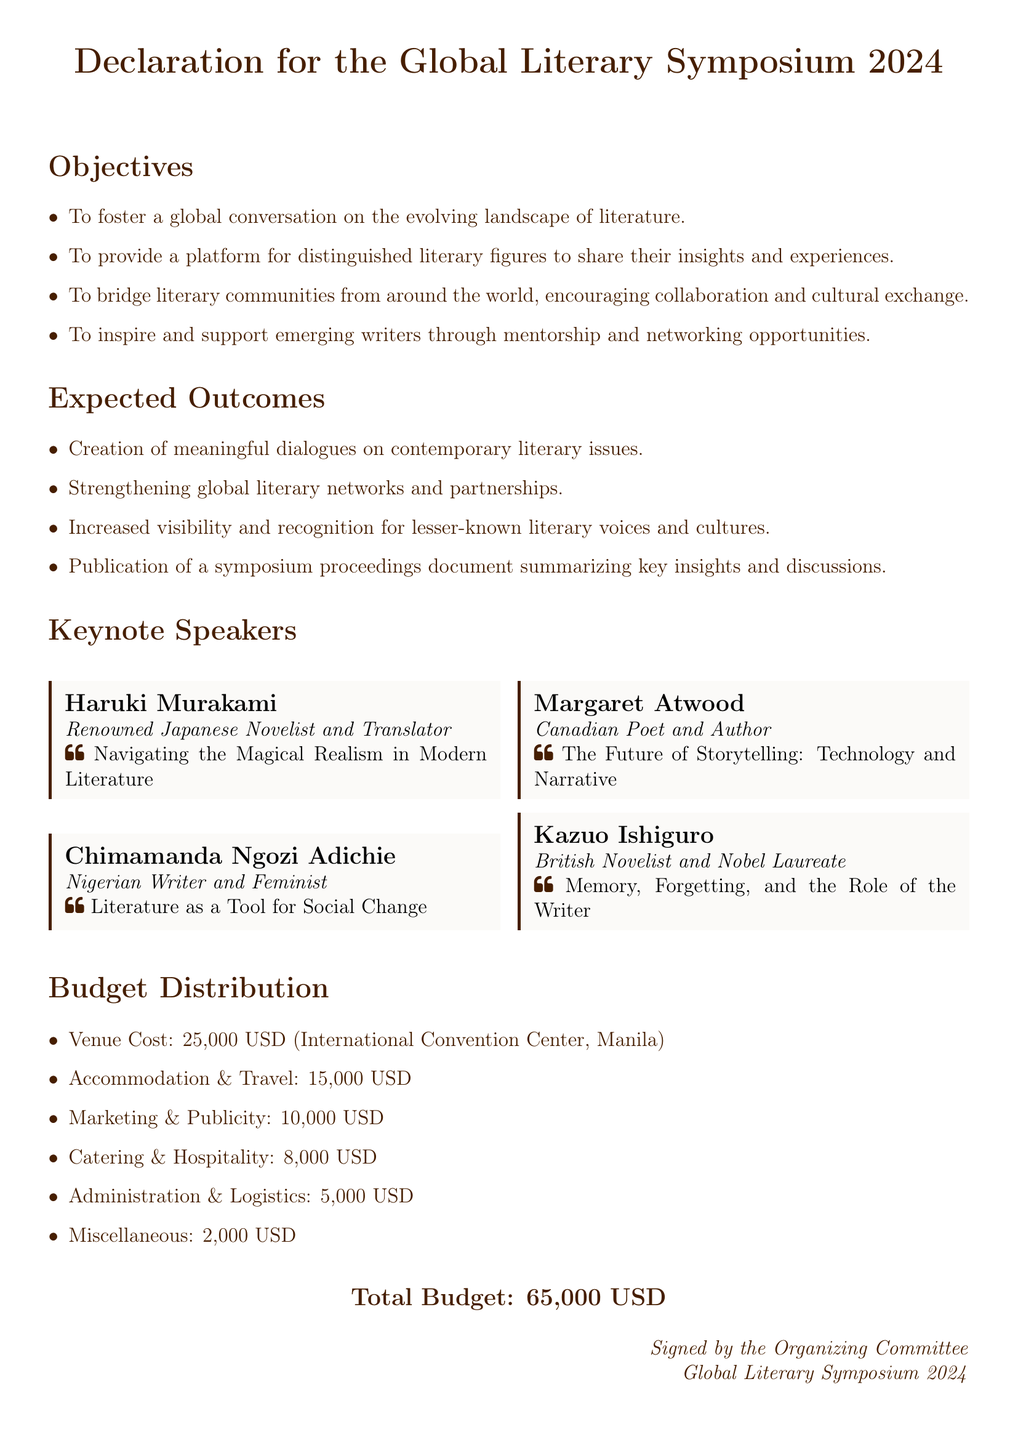What is the total budget for the symposium? The total budget is stated at the end of the document, which sums all expenses.
Answer: 65,000 USD Who is a keynote speaker from Nigeria? The document lists Chimamanda Ngozi Adichie as a speaker along with her identification as a Nigerian writer.
Answer: Chimamanda Ngozi Adichie How much is allocated for venue cost? The budget distribution includes a specific cost for the venue, noted within the document.
Answer: 25,000 USD What is one of the objectives of the symposium? The document outlines several objectives, focusing on global conversation and literary connections.
Answer: To foster a global conversation on the evolving landscape of literature What is expected as an outcome of the symposium? The document lists expected outcomes, including increased visibility for literary voices.
Answer: Increased visibility and recognition for lesser-known literary voices and cultures Which venue is hosting the symposium? The venue is specified in the budget distribution section, identifying the location of the event.
Answer: International Convention Center, Manila What is the budget for marketing and publicity? A specific amount for marketing and publicity is provided in the budget section of the document.
Answer: 10,000 USD Who is the author of the keynote topic "The Future of Storytelling"? The keynote topic is listed alongside the corresponding speaker in the document, identifying the author.
Answer: Margaret Atwood What type of event is being proposed? The title at the top of the document reveals the nature of the event.
Answer: Literary Symposium 